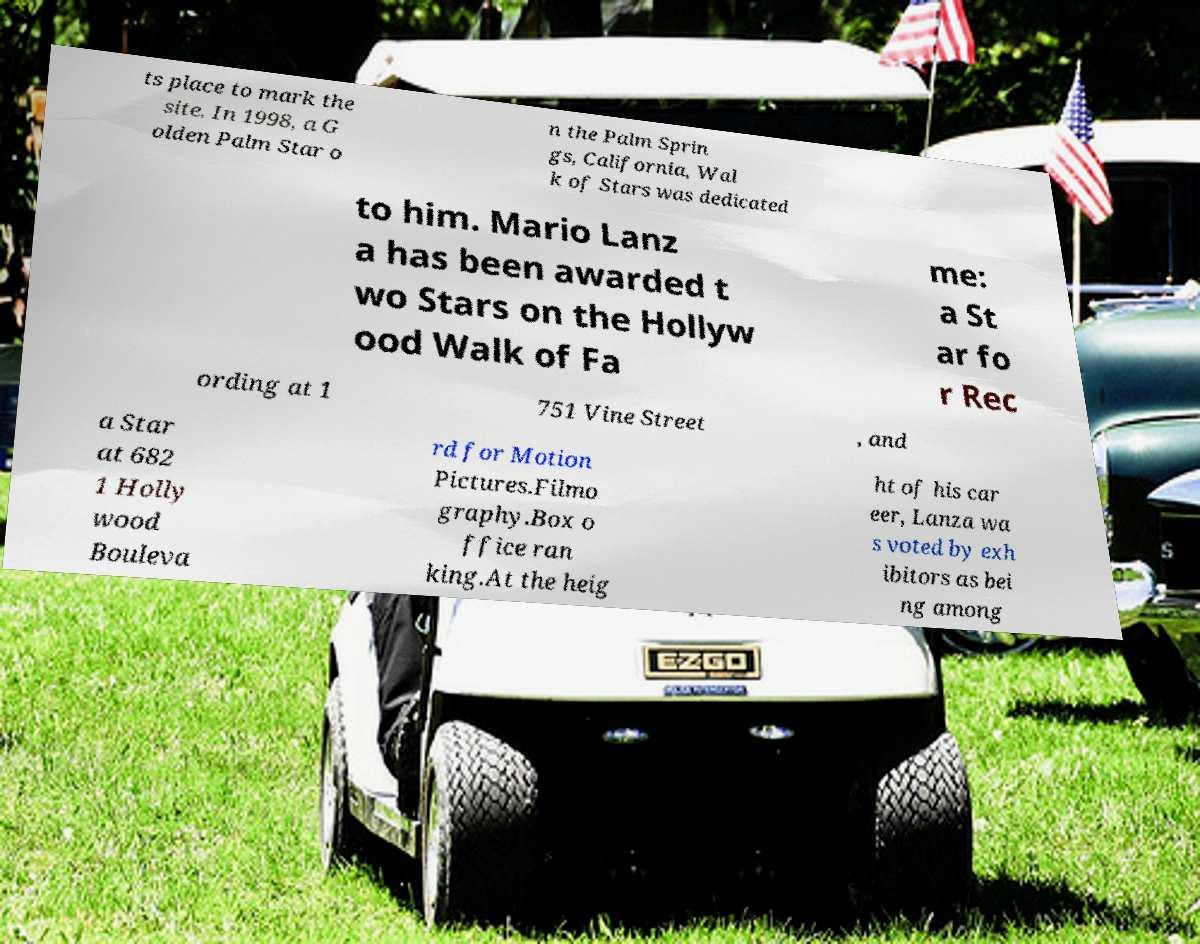I need the written content from this picture converted into text. Can you do that? ts place to mark the site. In 1998, a G olden Palm Star o n the Palm Sprin gs, California, Wal k of Stars was dedicated to him. Mario Lanz a has been awarded t wo Stars on the Hollyw ood Walk of Fa me: a St ar fo r Rec ording at 1 751 Vine Street , and a Star at 682 1 Holly wood Bouleva rd for Motion Pictures.Filmo graphy.Box o ffice ran king.At the heig ht of his car eer, Lanza wa s voted by exh ibitors as bei ng among 